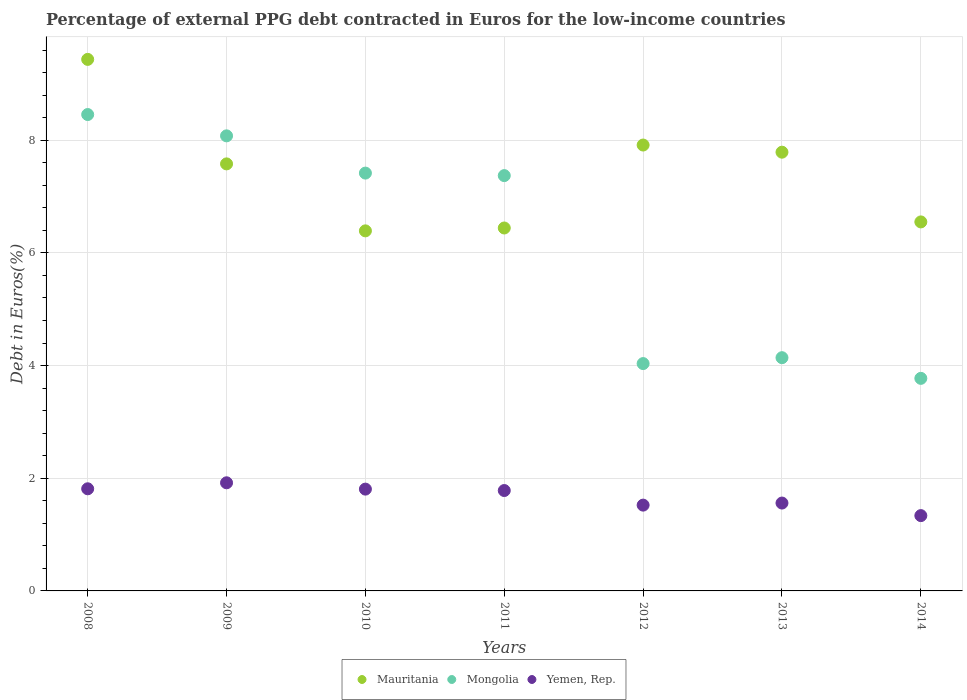Is the number of dotlines equal to the number of legend labels?
Your answer should be very brief. Yes. What is the percentage of external PPG debt contracted in Euros in Mongolia in 2014?
Provide a succinct answer. 3.77. Across all years, what is the maximum percentage of external PPG debt contracted in Euros in Mauritania?
Your answer should be very brief. 9.43. Across all years, what is the minimum percentage of external PPG debt contracted in Euros in Mauritania?
Provide a short and direct response. 6.39. In which year was the percentage of external PPG debt contracted in Euros in Mauritania minimum?
Keep it short and to the point. 2010. What is the total percentage of external PPG debt contracted in Euros in Mauritania in the graph?
Your answer should be compact. 52.1. What is the difference between the percentage of external PPG debt contracted in Euros in Mongolia in 2012 and that in 2014?
Provide a short and direct response. 0.26. What is the difference between the percentage of external PPG debt contracted in Euros in Mauritania in 2013 and the percentage of external PPG debt contracted in Euros in Yemen, Rep. in 2014?
Provide a short and direct response. 6.45. What is the average percentage of external PPG debt contracted in Euros in Mongolia per year?
Provide a short and direct response. 6.18. In the year 2011, what is the difference between the percentage of external PPG debt contracted in Euros in Mongolia and percentage of external PPG debt contracted in Euros in Mauritania?
Give a very brief answer. 0.93. In how many years, is the percentage of external PPG debt contracted in Euros in Mongolia greater than 1.6 %?
Make the answer very short. 7. What is the ratio of the percentage of external PPG debt contracted in Euros in Mongolia in 2008 to that in 2009?
Keep it short and to the point. 1.05. Is the difference between the percentage of external PPG debt contracted in Euros in Mongolia in 2009 and 2012 greater than the difference between the percentage of external PPG debt contracted in Euros in Mauritania in 2009 and 2012?
Ensure brevity in your answer.  Yes. What is the difference between the highest and the second highest percentage of external PPG debt contracted in Euros in Mongolia?
Offer a very short reply. 0.38. What is the difference between the highest and the lowest percentage of external PPG debt contracted in Euros in Yemen, Rep.?
Offer a very short reply. 0.58. In how many years, is the percentage of external PPG debt contracted in Euros in Mongolia greater than the average percentage of external PPG debt contracted in Euros in Mongolia taken over all years?
Your answer should be very brief. 4. Is it the case that in every year, the sum of the percentage of external PPG debt contracted in Euros in Mongolia and percentage of external PPG debt contracted in Euros in Yemen, Rep.  is greater than the percentage of external PPG debt contracted in Euros in Mauritania?
Your response must be concise. No. Does the percentage of external PPG debt contracted in Euros in Mongolia monotonically increase over the years?
Provide a short and direct response. No. Is the percentage of external PPG debt contracted in Euros in Mauritania strictly less than the percentage of external PPG debt contracted in Euros in Mongolia over the years?
Keep it short and to the point. No. How many years are there in the graph?
Your answer should be compact. 7. What is the difference between two consecutive major ticks on the Y-axis?
Your response must be concise. 2. Are the values on the major ticks of Y-axis written in scientific E-notation?
Give a very brief answer. No. Where does the legend appear in the graph?
Offer a very short reply. Bottom center. What is the title of the graph?
Your answer should be very brief. Percentage of external PPG debt contracted in Euros for the low-income countries. Does "Benin" appear as one of the legend labels in the graph?
Your response must be concise. No. What is the label or title of the X-axis?
Provide a short and direct response. Years. What is the label or title of the Y-axis?
Provide a short and direct response. Debt in Euros(%). What is the Debt in Euros(%) in Mauritania in 2008?
Your answer should be compact. 9.43. What is the Debt in Euros(%) of Mongolia in 2008?
Ensure brevity in your answer.  8.46. What is the Debt in Euros(%) of Yemen, Rep. in 2008?
Provide a succinct answer. 1.81. What is the Debt in Euros(%) of Mauritania in 2009?
Provide a succinct answer. 7.58. What is the Debt in Euros(%) in Mongolia in 2009?
Ensure brevity in your answer.  8.08. What is the Debt in Euros(%) in Yemen, Rep. in 2009?
Provide a succinct answer. 1.92. What is the Debt in Euros(%) in Mauritania in 2010?
Provide a short and direct response. 6.39. What is the Debt in Euros(%) of Mongolia in 2010?
Provide a short and direct response. 7.42. What is the Debt in Euros(%) in Yemen, Rep. in 2010?
Offer a very short reply. 1.81. What is the Debt in Euros(%) in Mauritania in 2011?
Make the answer very short. 6.44. What is the Debt in Euros(%) of Mongolia in 2011?
Keep it short and to the point. 7.37. What is the Debt in Euros(%) in Yemen, Rep. in 2011?
Your answer should be compact. 1.78. What is the Debt in Euros(%) of Mauritania in 2012?
Make the answer very short. 7.91. What is the Debt in Euros(%) in Mongolia in 2012?
Offer a terse response. 4.04. What is the Debt in Euros(%) of Yemen, Rep. in 2012?
Offer a very short reply. 1.52. What is the Debt in Euros(%) in Mauritania in 2013?
Provide a succinct answer. 7.79. What is the Debt in Euros(%) in Mongolia in 2013?
Your answer should be very brief. 4.14. What is the Debt in Euros(%) in Yemen, Rep. in 2013?
Ensure brevity in your answer.  1.56. What is the Debt in Euros(%) of Mauritania in 2014?
Provide a succinct answer. 6.55. What is the Debt in Euros(%) in Mongolia in 2014?
Provide a succinct answer. 3.77. What is the Debt in Euros(%) of Yemen, Rep. in 2014?
Your answer should be compact. 1.34. Across all years, what is the maximum Debt in Euros(%) in Mauritania?
Your answer should be compact. 9.43. Across all years, what is the maximum Debt in Euros(%) in Mongolia?
Make the answer very short. 8.46. Across all years, what is the maximum Debt in Euros(%) in Yemen, Rep.?
Your answer should be compact. 1.92. Across all years, what is the minimum Debt in Euros(%) of Mauritania?
Your response must be concise. 6.39. Across all years, what is the minimum Debt in Euros(%) in Mongolia?
Give a very brief answer. 3.77. Across all years, what is the minimum Debt in Euros(%) of Yemen, Rep.?
Offer a terse response. 1.34. What is the total Debt in Euros(%) in Mauritania in the graph?
Offer a very short reply. 52.1. What is the total Debt in Euros(%) of Mongolia in the graph?
Your answer should be very brief. 43.27. What is the total Debt in Euros(%) of Yemen, Rep. in the graph?
Offer a very short reply. 11.74. What is the difference between the Debt in Euros(%) in Mauritania in 2008 and that in 2009?
Keep it short and to the point. 1.85. What is the difference between the Debt in Euros(%) in Mongolia in 2008 and that in 2009?
Your response must be concise. 0.38. What is the difference between the Debt in Euros(%) of Yemen, Rep. in 2008 and that in 2009?
Your answer should be compact. -0.11. What is the difference between the Debt in Euros(%) of Mauritania in 2008 and that in 2010?
Provide a succinct answer. 3.04. What is the difference between the Debt in Euros(%) of Mongolia in 2008 and that in 2010?
Keep it short and to the point. 1.04. What is the difference between the Debt in Euros(%) of Yemen, Rep. in 2008 and that in 2010?
Your answer should be compact. 0.01. What is the difference between the Debt in Euros(%) in Mauritania in 2008 and that in 2011?
Your answer should be very brief. 2.99. What is the difference between the Debt in Euros(%) in Mongolia in 2008 and that in 2011?
Ensure brevity in your answer.  1.08. What is the difference between the Debt in Euros(%) of Yemen, Rep. in 2008 and that in 2011?
Your response must be concise. 0.03. What is the difference between the Debt in Euros(%) of Mauritania in 2008 and that in 2012?
Your response must be concise. 1.52. What is the difference between the Debt in Euros(%) in Mongolia in 2008 and that in 2012?
Offer a very short reply. 4.42. What is the difference between the Debt in Euros(%) of Yemen, Rep. in 2008 and that in 2012?
Offer a very short reply. 0.29. What is the difference between the Debt in Euros(%) in Mauritania in 2008 and that in 2013?
Give a very brief answer. 1.65. What is the difference between the Debt in Euros(%) of Mongolia in 2008 and that in 2013?
Provide a short and direct response. 4.32. What is the difference between the Debt in Euros(%) of Yemen, Rep. in 2008 and that in 2013?
Make the answer very short. 0.25. What is the difference between the Debt in Euros(%) in Mauritania in 2008 and that in 2014?
Ensure brevity in your answer.  2.88. What is the difference between the Debt in Euros(%) in Mongolia in 2008 and that in 2014?
Make the answer very short. 4.68. What is the difference between the Debt in Euros(%) in Yemen, Rep. in 2008 and that in 2014?
Your answer should be compact. 0.48. What is the difference between the Debt in Euros(%) in Mauritania in 2009 and that in 2010?
Offer a terse response. 1.19. What is the difference between the Debt in Euros(%) of Mongolia in 2009 and that in 2010?
Offer a very short reply. 0.66. What is the difference between the Debt in Euros(%) of Yemen, Rep. in 2009 and that in 2010?
Provide a succinct answer. 0.11. What is the difference between the Debt in Euros(%) in Mauritania in 2009 and that in 2011?
Keep it short and to the point. 1.14. What is the difference between the Debt in Euros(%) of Mongolia in 2009 and that in 2011?
Ensure brevity in your answer.  0.71. What is the difference between the Debt in Euros(%) in Yemen, Rep. in 2009 and that in 2011?
Provide a succinct answer. 0.14. What is the difference between the Debt in Euros(%) in Mauritania in 2009 and that in 2012?
Your answer should be compact. -0.33. What is the difference between the Debt in Euros(%) in Mongolia in 2009 and that in 2012?
Your answer should be very brief. 4.04. What is the difference between the Debt in Euros(%) of Yemen, Rep. in 2009 and that in 2012?
Provide a succinct answer. 0.4. What is the difference between the Debt in Euros(%) in Mauritania in 2009 and that in 2013?
Keep it short and to the point. -0.21. What is the difference between the Debt in Euros(%) of Mongolia in 2009 and that in 2013?
Give a very brief answer. 3.94. What is the difference between the Debt in Euros(%) in Yemen, Rep. in 2009 and that in 2013?
Make the answer very short. 0.36. What is the difference between the Debt in Euros(%) of Mongolia in 2009 and that in 2014?
Offer a terse response. 4.3. What is the difference between the Debt in Euros(%) of Yemen, Rep. in 2009 and that in 2014?
Keep it short and to the point. 0.58. What is the difference between the Debt in Euros(%) in Mauritania in 2010 and that in 2011?
Make the answer very short. -0.05. What is the difference between the Debt in Euros(%) of Mongolia in 2010 and that in 2011?
Provide a succinct answer. 0.04. What is the difference between the Debt in Euros(%) in Yemen, Rep. in 2010 and that in 2011?
Make the answer very short. 0.03. What is the difference between the Debt in Euros(%) in Mauritania in 2010 and that in 2012?
Offer a terse response. -1.52. What is the difference between the Debt in Euros(%) in Mongolia in 2010 and that in 2012?
Offer a very short reply. 3.38. What is the difference between the Debt in Euros(%) of Yemen, Rep. in 2010 and that in 2012?
Provide a short and direct response. 0.28. What is the difference between the Debt in Euros(%) of Mauritania in 2010 and that in 2013?
Ensure brevity in your answer.  -1.4. What is the difference between the Debt in Euros(%) of Mongolia in 2010 and that in 2013?
Make the answer very short. 3.28. What is the difference between the Debt in Euros(%) in Yemen, Rep. in 2010 and that in 2013?
Your answer should be very brief. 0.25. What is the difference between the Debt in Euros(%) in Mauritania in 2010 and that in 2014?
Give a very brief answer. -0.16. What is the difference between the Debt in Euros(%) in Mongolia in 2010 and that in 2014?
Make the answer very short. 3.64. What is the difference between the Debt in Euros(%) in Yemen, Rep. in 2010 and that in 2014?
Keep it short and to the point. 0.47. What is the difference between the Debt in Euros(%) in Mauritania in 2011 and that in 2012?
Offer a terse response. -1.47. What is the difference between the Debt in Euros(%) of Mongolia in 2011 and that in 2012?
Provide a short and direct response. 3.34. What is the difference between the Debt in Euros(%) of Yemen, Rep. in 2011 and that in 2012?
Your answer should be very brief. 0.26. What is the difference between the Debt in Euros(%) of Mauritania in 2011 and that in 2013?
Keep it short and to the point. -1.35. What is the difference between the Debt in Euros(%) in Mongolia in 2011 and that in 2013?
Keep it short and to the point. 3.23. What is the difference between the Debt in Euros(%) of Yemen, Rep. in 2011 and that in 2013?
Your answer should be compact. 0.22. What is the difference between the Debt in Euros(%) of Mauritania in 2011 and that in 2014?
Keep it short and to the point. -0.11. What is the difference between the Debt in Euros(%) in Mongolia in 2011 and that in 2014?
Your answer should be compact. 3.6. What is the difference between the Debt in Euros(%) in Yemen, Rep. in 2011 and that in 2014?
Your answer should be compact. 0.45. What is the difference between the Debt in Euros(%) in Mauritania in 2012 and that in 2013?
Keep it short and to the point. 0.13. What is the difference between the Debt in Euros(%) in Mongolia in 2012 and that in 2013?
Keep it short and to the point. -0.1. What is the difference between the Debt in Euros(%) of Yemen, Rep. in 2012 and that in 2013?
Your answer should be compact. -0.04. What is the difference between the Debt in Euros(%) in Mauritania in 2012 and that in 2014?
Your answer should be compact. 1.36. What is the difference between the Debt in Euros(%) of Mongolia in 2012 and that in 2014?
Offer a very short reply. 0.26. What is the difference between the Debt in Euros(%) of Yemen, Rep. in 2012 and that in 2014?
Ensure brevity in your answer.  0.19. What is the difference between the Debt in Euros(%) in Mauritania in 2013 and that in 2014?
Keep it short and to the point. 1.24. What is the difference between the Debt in Euros(%) of Mongolia in 2013 and that in 2014?
Give a very brief answer. 0.37. What is the difference between the Debt in Euros(%) of Yemen, Rep. in 2013 and that in 2014?
Offer a terse response. 0.22. What is the difference between the Debt in Euros(%) in Mauritania in 2008 and the Debt in Euros(%) in Mongolia in 2009?
Give a very brief answer. 1.36. What is the difference between the Debt in Euros(%) of Mauritania in 2008 and the Debt in Euros(%) of Yemen, Rep. in 2009?
Offer a terse response. 7.52. What is the difference between the Debt in Euros(%) of Mongolia in 2008 and the Debt in Euros(%) of Yemen, Rep. in 2009?
Keep it short and to the point. 6.54. What is the difference between the Debt in Euros(%) in Mauritania in 2008 and the Debt in Euros(%) in Mongolia in 2010?
Ensure brevity in your answer.  2.02. What is the difference between the Debt in Euros(%) in Mauritania in 2008 and the Debt in Euros(%) in Yemen, Rep. in 2010?
Your response must be concise. 7.63. What is the difference between the Debt in Euros(%) of Mongolia in 2008 and the Debt in Euros(%) of Yemen, Rep. in 2010?
Your answer should be compact. 6.65. What is the difference between the Debt in Euros(%) of Mauritania in 2008 and the Debt in Euros(%) of Mongolia in 2011?
Offer a terse response. 2.06. What is the difference between the Debt in Euros(%) of Mauritania in 2008 and the Debt in Euros(%) of Yemen, Rep. in 2011?
Offer a very short reply. 7.65. What is the difference between the Debt in Euros(%) of Mongolia in 2008 and the Debt in Euros(%) of Yemen, Rep. in 2011?
Give a very brief answer. 6.67. What is the difference between the Debt in Euros(%) in Mauritania in 2008 and the Debt in Euros(%) in Mongolia in 2012?
Offer a very short reply. 5.4. What is the difference between the Debt in Euros(%) in Mauritania in 2008 and the Debt in Euros(%) in Yemen, Rep. in 2012?
Keep it short and to the point. 7.91. What is the difference between the Debt in Euros(%) of Mongolia in 2008 and the Debt in Euros(%) of Yemen, Rep. in 2012?
Offer a terse response. 6.93. What is the difference between the Debt in Euros(%) of Mauritania in 2008 and the Debt in Euros(%) of Mongolia in 2013?
Provide a succinct answer. 5.29. What is the difference between the Debt in Euros(%) in Mauritania in 2008 and the Debt in Euros(%) in Yemen, Rep. in 2013?
Give a very brief answer. 7.88. What is the difference between the Debt in Euros(%) in Mongolia in 2008 and the Debt in Euros(%) in Yemen, Rep. in 2013?
Provide a short and direct response. 6.9. What is the difference between the Debt in Euros(%) in Mauritania in 2008 and the Debt in Euros(%) in Mongolia in 2014?
Offer a very short reply. 5.66. What is the difference between the Debt in Euros(%) of Mauritania in 2008 and the Debt in Euros(%) of Yemen, Rep. in 2014?
Provide a succinct answer. 8.1. What is the difference between the Debt in Euros(%) of Mongolia in 2008 and the Debt in Euros(%) of Yemen, Rep. in 2014?
Provide a short and direct response. 7.12. What is the difference between the Debt in Euros(%) in Mauritania in 2009 and the Debt in Euros(%) in Mongolia in 2010?
Your response must be concise. 0.16. What is the difference between the Debt in Euros(%) in Mauritania in 2009 and the Debt in Euros(%) in Yemen, Rep. in 2010?
Ensure brevity in your answer.  5.77. What is the difference between the Debt in Euros(%) of Mongolia in 2009 and the Debt in Euros(%) of Yemen, Rep. in 2010?
Ensure brevity in your answer.  6.27. What is the difference between the Debt in Euros(%) in Mauritania in 2009 and the Debt in Euros(%) in Mongolia in 2011?
Keep it short and to the point. 0.21. What is the difference between the Debt in Euros(%) of Mauritania in 2009 and the Debt in Euros(%) of Yemen, Rep. in 2011?
Provide a succinct answer. 5.8. What is the difference between the Debt in Euros(%) in Mongolia in 2009 and the Debt in Euros(%) in Yemen, Rep. in 2011?
Your response must be concise. 6.3. What is the difference between the Debt in Euros(%) of Mauritania in 2009 and the Debt in Euros(%) of Mongolia in 2012?
Your answer should be compact. 3.54. What is the difference between the Debt in Euros(%) in Mauritania in 2009 and the Debt in Euros(%) in Yemen, Rep. in 2012?
Make the answer very short. 6.06. What is the difference between the Debt in Euros(%) in Mongolia in 2009 and the Debt in Euros(%) in Yemen, Rep. in 2012?
Offer a very short reply. 6.55. What is the difference between the Debt in Euros(%) in Mauritania in 2009 and the Debt in Euros(%) in Mongolia in 2013?
Your answer should be very brief. 3.44. What is the difference between the Debt in Euros(%) in Mauritania in 2009 and the Debt in Euros(%) in Yemen, Rep. in 2013?
Provide a short and direct response. 6.02. What is the difference between the Debt in Euros(%) in Mongolia in 2009 and the Debt in Euros(%) in Yemen, Rep. in 2013?
Give a very brief answer. 6.52. What is the difference between the Debt in Euros(%) of Mauritania in 2009 and the Debt in Euros(%) of Mongolia in 2014?
Provide a succinct answer. 3.81. What is the difference between the Debt in Euros(%) in Mauritania in 2009 and the Debt in Euros(%) in Yemen, Rep. in 2014?
Your response must be concise. 6.24. What is the difference between the Debt in Euros(%) of Mongolia in 2009 and the Debt in Euros(%) of Yemen, Rep. in 2014?
Make the answer very short. 6.74. What is the difference between the Debt in Euros(%) of Mauritania in 2010 and the Debt in Euros(%) of Mongolia in 2011?
Offer a terse response. -0.98. What is the difference between the Debt in Euros(%) of Mauritania in 2010 and the Debt in Euros(%) of Yemen, Rep. in 2011?
Provide a succinct answer. 4.61. What is the difference between the Debt in Euros(%) of Mongolia in 2010 and the Debt in Euros(%) of Yemen, Rep. in 2011?
Provide a succinct answer. 5.63. What is the difference between the Debt in Euros(%) of Mauritania in 2010 and the Debt in Euros(%) of Mongolia in 2012?
Ensure brevity in your answer.  2.36. What is the difference between the Debt in Euros(%) of Mauritania in 2010 and the Debt in Euros(%) of Yemen, Rep. in 2012?
Your response must be concise. 4.87. What is the difference between the Debt in Euros(%) in Mongolia in 2010 and the Debt in Euros(%) in Yemen, Rep. in 2012?
Your answer should be compact. 5.89. What is the difference between the Debt in Euros(%) of Mauritania in 2010 and the Debt in Euros(%) of Mongolia in 2013?
Provide a succinct answer. 2.25. What is the difference between the Debt in Euros(%) of Mauritania in 2010 and the Debt in Euros(%) of Yemen, Rep. in 2013?
Provide a succinct answer. 4.83. What is the difference between the Debt in Euros(%) in Mongolia in 2010 and the Debt in Euros(%) in Yemen, Rep. in 2013?
Your response must be concise. 5.86. What is the difference between the Debt in Euros(%) of Mauritania in 2010 and the Debt in Euros(%) of Mongolia in 2014?
Provide a short and direct response. 2.62. What is the difference between the Debt in Euros(%) of Mauritania in 2010 and the Debt in Euros(%) of Yemen, Rep. in 2014?
Make the answer very short. 5.05. What is the difference between the Debt in Euros(%) of Mongolia in 2010 and the Debt in Euros(%) of Yemen, Rep. in 2014?
Offer a terse response. 6.08. What is the difference between the Debt in Euros(%) in Mauritania in 2011 and the Debt in Euros(%) in Mongolia in 2012?
Provide a succinct answer. 2.41. What is the difference between the Debt in Euros(%) in Mauritania in 2011 and the Debt in Euros(%) in Yemen, Rep. in 2012?
Your answer should be very brief. 4.92. What is the difference between the Debt in Euros(%) of Mongolia in 2011 and the Debt in Euros(%) of Yemen, Rep. in 2012?
Keep it short and to the point. 5.85. What is the difference between the Debt in Euros(%) in Mauritania in 2011 and the Debt in Euros(%) in Mongolia in 2013?
Your answer should be very brief. 2.3. What is the difference between the Debt in Euros(%) in Mauritania in 2011 and the Debt in Euros(%) in Yemen, Rep. in 2013?
Offer a terse response. 4.88. What is the difference between the Debt in Euros(%) in Mongolia in 2011 and the Debt in Euros(%) in Yemen, Rep. in 2013?
Make the answer very short. 5.81. What is the difference between the Debt in Euros(%) of Mauritania in 2011 and the Debt in Euros(%) of Mongolia in 2014?
Ensure brevity in your answer.  2.67. What is the difference between the Debt in Euros(%) in Mauritania in 2011 and the Debt in Euros(%) in Yemen, Rep. in 2014?
Provide a short and direct response. 5.11. What is the difference between the Debt in Euros(%) in Mongolia in 2011 and the Debt in Euros(%) in Yemen, Rep. in 2014?
Provide a succinct answer. 6.04. What is the difference between the Debt in Euros(%) in Mauritania in 2012 and the Debt in Euros(%) in Mongolia in 2013?
Give a very brief answer. 3.77. What is the difference between the Debt in Euros(%) of Mauritania in 2012 and the Debt in Euros(%) of Yemen, Rep. in 2013?
Your answer should be compact. 6.35. What is the difference between the Debt in Euros(%) in Mongolia in 2012 and the Debt in Euros(%) in Yemen, Rep. in 2013?
Provide a succinct answer. 2.48. What is the difference between the Debt in Euros(%) of Mauritania in 2012 and the Debt in Euros(%) of Mongolia in 2014?
Keep it short and to the point. 4.14. What is the difference between the Debt in Euros(%) of Mauritania in 2012 and the Debt in Euros(%) of Yemen, Rep. in 2014?
Keep it short and to the point. 6.58. What is the difference between the Debt in Euros(%) of Mongolia in 2012 and the Debt in Euros(%) of Yemen, Rep. in 2014?
Your answer should be very brief. 2.7. What is the difference between the Debt in Euros(%) of Mauritania in 2013 and the Debt in Euros(%) of Mongolia in 2014?
Provide a succinct answer. 4.01. What is the difference between the Debt in Euros(%) of Mauritania in 2013 and the Debt in Euros(%) of Yemen, Rep. in 2014?
Provide a short and direct response. 6.45. What is the difference between the Debt in Euros(%) of Mongolia in 2013 and the Debt in Euros(%) of Yemen, Rep. in 2014?
Keep it short and to the point. 2.8. What is the average Debt in Euros(%) of Mauritania per year?
Make the answer very short. 7.44. What is the average Debt in Euros(%) in Mongolia per year?
Your answer should be very brief. 6.18. What is the average Debt in Euros(%) in Yemen, Rep. per year?
Your answer should be compact. 1.68. In the year 2008, what is the difference between the Debt in Euros(%) in Mauritania and Debt in Euros(%) in Mongolia?
Offer a terse response. 0.98. In the year 2008, what is the difference between the Debt in Euros(%) of Mauritania and Debt in Euros(%) of Yemen, Rep.?
Offer a very short reply. 7.62. In the year 2008, what is the difference between the Debt in Euros(%) of Mongolia and Debt in Euros(%) of Yemen, Rep.?
Give a very brief answer. 6.64. In the year 2009, what is the difference between the Debt in Euros(%) of Mauritania and Debt in Euros(%) of Mongolia?
Keep it short and to the point. -0.5. In the year 2009, what is the difference between the Debt in Euros(%) of Mauritania and Debt in Euros(%) of Yemen, Rep.?
Give a very brief answer. 5.66. In the year 2009, what is the difference between the Debt in Euros(%) in Mongolia and Debt in Euros(%) in Yemen, Rep.?
Provide a short and direct response. 6.16. In the year 2010, what is the difference between the Debt in Euros(%) in Mauritania and Debt in Euros(%) in Mongolia?
Provide a succinct answer. -1.03. In the year 2010, what is the difference between the Debt in Euros(%) in Mauritania and Debt in Euros(%) in Yemen, Rep.?
Offer a very short reply. 4.58. In the year 2010, what is the difference between the Debt in Euros(%) in Mongolia and Debt in Euros(%) in Yemen, Rep.?
Provide a short and direct response. 5.61. In the year 2011, what is the difference between the Debt in Euros(%) of Mauritania and Debt in Euros(%) of Mongolia?
Your answer should be compact. -0.93. In the year 2011, what is the difference between the Debt in Euros(%) in Mauritania and Debt in Euros(%) in Yemen, Rep.?
Offer a terse response. 4.66. In the year 2011, what is the difference between the Debt in Euros(%) in Mongolia and Debt in Euros(%) in Yemen, Rep.?
Your response must be concise. 5.59. In the year 2012, what is the difference between the Debt in Euros(%) of Mauritania and Debt in Euros(%) of Mongolia?
Your answer should be compact. 3.88. In the year 2012, what is the difference between the Debt in Euros(%) in Mauritania and Debt in Euros(%) in Yemen, Rep.?
Keep it short and to the point. 6.39. In the year 2012, what is the difference between the Debt in Euros(%) in Mongolia and Debt in Euros(%) in Yemen, Rep.?
Offer a terse response. 2.51. In the year 2013, what is the difference between the Debt in Euros(%) in Mauritania and Debt in Euros(%) in Mongolia?
Offer a terse response. 3.65. In the year 2013, what is the difference between the Debt in Euros(%) in Mauritania and Debt in Euros(%) in Yemen, Rep.?
Offer a terse response. 6.23. In the year 2013, what is the difference between the Debt in Euros(%) in Mongolia and Debt in Euros(%) in Yemen, Rep.?
Give a very brief answer. 2.58. In the year 2014, what is the difference between the Debt in Euros(%) in Mauritania and Debt in Euros(%) in Mongolia?
Ensure brevity in your answer.  2.78. In the year 2014, what is the difference between the Debt in Euros(%) in Mauritania and Debt in Euros(%) in Yemen, Rep.?
Provide a succinct answer. 5.21. In the year 2014, what is the difference between the Debt in Euros(%) in Mongolia and Debt in Euros(%) in Yemen, Rep.?
Keep it short and to the point. 2.44. What is the ratio of the Debt in Euros(%) in Mauritania in 2008 to that in 2009?
Give a very brief answer. 1.24. What is the ratio of the Debt in Euros(%) of Mongolia in 2008 to that in 2009?
Offer a terse response. 1.05. What is the ratio of the Debt in Euros(%) of Yemen, Rep. in 2008 to that in 2009?
Your answer should be very brief. 0.94. What is the ratio of the Debt in Euros(%) in Mauritania in 2008 to that in 2010?
Ensure brevity in your answer.  1.48. What is the ratio of the Debt in Euros(%) in Mongolia in 2008 to that in 2010?
Offer a very short reply. 1.14. What is the ratio of the Debt in Euros(%) of Yemen, Rep. in 2008 to that in 2010?
Provide a succinct answer. 1. What is the ratio of the Debt in Euros(%) in Mauritania in 2008 to that in 2011?
Your answer should be compact. 1.46. What is the ratio of the Debt in Euros(%) in Mongolia in 2008 to that in 2011?
Your answer should be compact. 1.15. What is the ratio of the Debt in Euros(%) in Yemen, Rep. in 2008 to that in 2011?
Keep it short and to the point. 1.02. What is the ratio of the Debt in Euros(%) in Mauritania in 2008 to that in 2012?
Your answer should be compact. 1.19. What is the ratio of the Debt in Euros(%) of Mongolia in 2008 to that in 2012?
Keep it short and to the point. 2.1. What is the ratio of the Debt in Euros(%) of Yemen, Rep. in 2008 to that in 2012?
Give a very brief answer. 1.19. What is the ratio of the Debt in Euros(%) of Mauritania in 2008 to that in 2013?
Ensure brevity in your answer.  1.21. What is the ratio of the Debt in Euros(%) of Mongolia in 2008 to that in 2013?
Give a very brief answer. 2.04. What is the ratio of the Debt in Euros(%) in Yemen, Rep. in 2008 to that in 2013?
Give a very brief answer. 1.16. What is the ratio of the Debt in Euros(%) in Mauritania in 2008 to that in 2014?
Offer a very short reply. 1.44. What is the ratio of the Debt in Euros(%) of Mongolia in 2008 to that in 2014?
Provide a succinct answer. 2.24. What is the ratio of the Debt in Euros(%) of Yemen, Rep. in 2008 to that in 2014?
Provide a short and direct response. 1.36. What is the ratio of the Debt in Euros(%) in Mauritania in 2009 to that in 2010?
Offer a terse response. 1.19. What is the ratio of the Debt in Euros(%) in Mongolia in 2009 to that in 2010?
Provide a succinct answer. 1.09. What is the ratio of the Debt in Euros(%) in Yemen, Rep. in 2009 to that in 2010?
Give a very brief answer. 1.06. What is the ratio of the Debt in Euros(%) in Mauritania in 2009 to that in 2011?
Your answer should be very brief. 1.18. What is the ratio of the Debt in Euros(%) in Mongolia in 2009 to that in 2011?
Ensure brevity in your answer.  1.1. What is the ratio of the Debt in Euros(%) in Yemen, Rep. in 2009 to that in 2011?
Offer a very short reply. 1.08. What is the ratio of the Debt in Euros(%) in Mauritania in 2009 to that in 2012?
Provide a short and direct response. 0.96. What is the ratio of the Debt in Euros(%) in Mongolia in 2009 to that in 2012?
Offer a very short reply. 2. What is the ratio of the Debt in Euros(%) in Yemen, Rep. in 2009 to that in 2012?
Ensure brevity in your answer.  1.26. What is the ratio of the Debt in Euros(%) in Mauritania in 2009 to that in 2013?
Provide a succinct answer. 0.97. What is the ratio of the Debt in Euros(%) in Mongolia in 2009 to that in 2013?
Provide a short and direct response. 1.95. What is the ratio of the Debt in Euros(%) of Yemen, Rep. in 2009 to that in 2013?
Provide a short and direct response. 1.23. What is the ratio of the Debt in Euros(%) of Mauritania in 2009 to that in 2014?
Provide a short and direct response. 1.16. What is the ratio of the Debt in Euros(%) of Mongolia in 2009 to that in 2014?
Offer a very short reply. 2.14. What is the ratio of the Debt in Euros(%) of Yemen, Rep. in 2009 to that in 2014?
Keep it short and to the point. 1.44. What is the ratio of the Debt in Euros(%) in Mongolia in 2010 to that in 2011?
Keep it short and to the point. 1.01. What is the ratio of the Debt in Euros(%) of Mauritania in 2010 to that in 2012?
Ensure brevity in your answer.  0.81. What is the ratio of the Debt in Euros(%) in Mongolia in 2010 to that in 2012?
Provide a succinct answer. 1.84. What is the ratio of the Debt in Euros(%) in Yemen, Rep. in 2010 to that in 2012?
Provide a succinct answer. 1.19. What is the ratio of the Debt in Euros(%) of Mauritania in 2010 to that in 2013?
Your answer should be compact. 0.82. What is the ratio of the Debt in Euros(%) of Mongolia in 2010 to that in 2013?
Keep it short and to the point. 1.79. What is the ratio of the Debt in Euros(%) of Yemen, Rep. in 2010 to that in 2013?
Offer a terse response. 1.16. What is the ratio of the Debt in Euros(%) in Mauritania in 2010 to that in 2014?
Ensure brevity in your answer.  0.98. What is the ratio of the Debt in Euros(%) in Mongolia in 2010 to that in 2014?
Make the answer very short. 1.97. What is the ratio of the Debt in Euros(%) in Yemen, Rep. in 2010 to that in 2014?
Your answer should be compact. 1.35. What is the ratio of the Debt in Euros(%) of Mauritania in 2011 to that in 2012?
Your response must be concise. 0.81. What is the ratio of the Debt in Euros(%) of Mongolia in 2011 to that in 2012?
Your answer should be compact. 1.83. What is the ratio of the Debt in Euros(%) in Yemen, Rep. in 2011 to that in 2012?
Offer a terse response. 1.17. What is the ratio of the Debt in Euros(%) in Mauritania in 2011 to that in 2013?
Offer a very short reply. 0.83. What is the ratio of the Debt in Euros(%) of Mongolia in 2011 to that in 2013?
Offer a very short reply. 1.78. What is the ratio of the Debt in Euros(%) in Yemen, Rep. in 2011 to that in 2013?
Provide a short and direct response. 1.14. What is the ratio of the Debt in Euros(%) of Mauritania in 2011 to that in 2014?
Ensure brevity in your answer.  0.98. What is the ratio of the Debt in Euros(%) in Mongolia in 2011 to that in 2014?
Your answer should be compact. 1.95. What is the ratio of the Debt in Euros(%) in Yemen, Rep. in 2011 to that in 2014?
Make the answer very short. 1.33. What is the ratio of the Debt in Euros(%) in Mauritania in 2012 to that in 2013?
Make the answer very short. 1.02. What is the ratio of the Debt in Euros(%) in Mongolia in 2012 to that in 2013?
Keep it short and to the point. 0.97. What is the ratio of the Debt in Euros(%) in Yemen, Rep. in 2012 to that in 2013?
Give a very brief answer. 0.98. What is the ratio of the Debt in Euros(%) of Mauritania in 2012 to that in 2014?
Provide a short and direct response. 1.21. What is the ratio of the Debt in Euros(%) in Mongolia in 2012 to that in 2014?
Give a very brief answer. 1.07. What is the ratio of the Debt in Euros(%) of Yemen, Rep. in 2012 to that in 2014?
Provide a short and direct response. 1.14. What is the ratio of the Debt in Euros(%) in Mauritania in 2013 to that in 2014?
Your response must be concise. 1.19. What is the ratio of the Debt in Euros(%) in Mongolia in 2013 to that in 2014?
Your response must be concise. 1.1. What is the ratio of the Debt in Euros(%) in Yemen, Rep. in 2013 to that in 2014?
Keep it short and to the point. 1.17. What is the difference between the highest and the second highest Debt in Euros(%) of Mauritania?
Ensure brevity in your answer.  1.52. What is the difference between the highest and the second highest Debt in Euros(%) in Mongolia?
Give a very brief answer. 0.38. What is the difference between the highest and the second highest Debt in Euros(%) in Yemen, Rep.?
Provide a succinct answer. 0.11. What is the difference between the highest and the lowest Debt in Euros(%) of Mauritania?
Offer a very short reply. 3.04. What is the difference between the highest and the lowest Debt in Euros(%) in Mongolia?
Ensure brevity in your answer.  4.68. What is the difference between the highest and the lowest Debt in Euros(%) in Yemen, Rep.?
Offer a terse response. 0.58. 